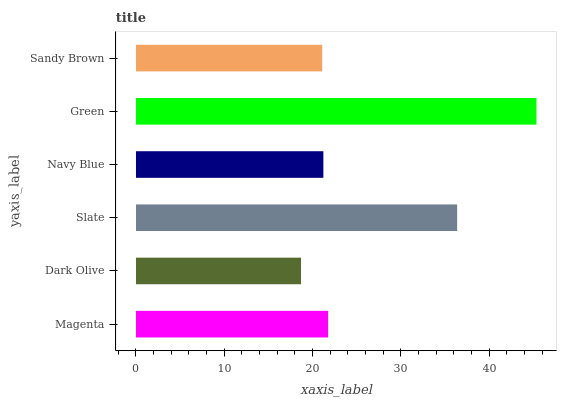Is Dark Olive the minimum?
Answer yes or no. Yes. Is Green the maximum?
Answer yes or no. Yes. Is Slate the minimum?
Answer yes or no. No. Is Slate the maximum?
Answer yes or no. No. Is Slate greater than Dark Olive?
Answer yes or no. Yes. Is Dark Olive less than Slate?
Answer yes or no. Yes. Is Dark Olive greater than Slate?
Answer yes or no. No. Is Slate less than Dark Olive?
Answer yes or no. No. Is Magenta the high median?
Answer yes or no. Yes. Is Navy Blue the low median?
Answer yes or no. Yes. Is Green the high median?
Answer yes or no. No. Is Dark Olive the low median?
Answer yes or no. No. 